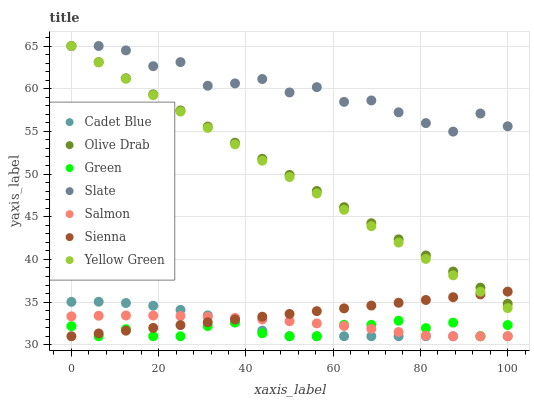Does Green have the minimum area under the curve?
Answer yes or no. Yes. Does Slate have the maximum area under the curve?
Answer yes or no. Yes. Does Yellow Green have the minimum area under the curve?
Answer yes or no. No. Does Yellow Green have the maximum area under the curve?
Answer yes or no. No. Is Sienna the smoothest?
Answer yes or no. Yes. Is Slate the roughest?
Answer yes or no. Yes. Is Yellow Green the smoothest?
Answer yes or no. No. Is Yellow Green the roughest?
Answer yes or no. No. Does Cadet Blue have the lowest value?
Answer yes or no. Yes. Does Yellow Green have the lowest value?
Answer yes or no. No. Does Olive Drab have the highest value?
Answer yes or no. Yes. Does Salmon have the highest value?
Answer yes or no. No. Is Salmon less than Yellow Green?
Answer yes or no. Yes. Is Olive Drab greater than Green?
Answer yes or no. Yes. Does Olive Drab intersect Yellow Green?
Answer yes or no. Yes. Is Olive Drab less than Yellow Green?
Answer yes or no. No. Is Olive Drab greater than Yellow Green?
Answer yes or no. No. Does Salmon intersect Yellow Green?
Answer yes or no. No. 